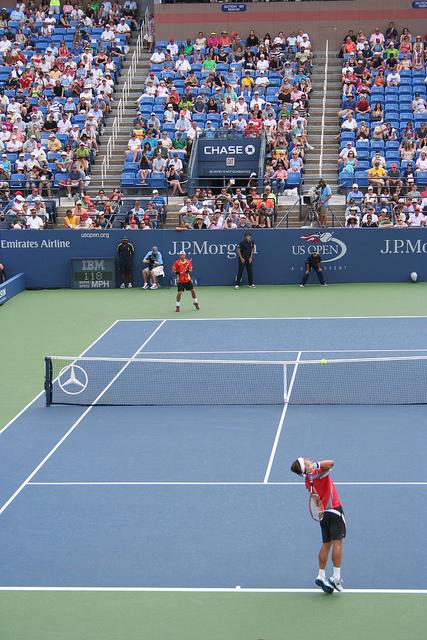Is there a Mercedes logo on the tennis court?
Keep it brief. Yes. What color are the seats the crowd is sitting on?
Keep it brief. Blue. Where was this photo taken?
Be succinct. Tennis court. 